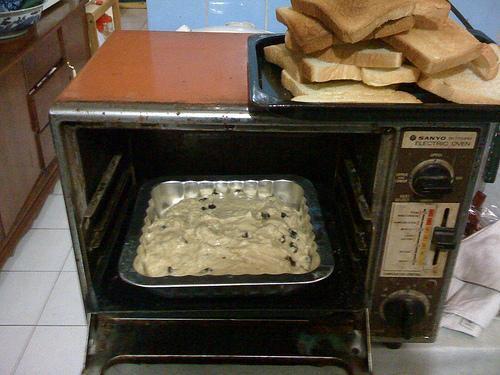How many items are in the oven?
Give a very brief answer. 1. 